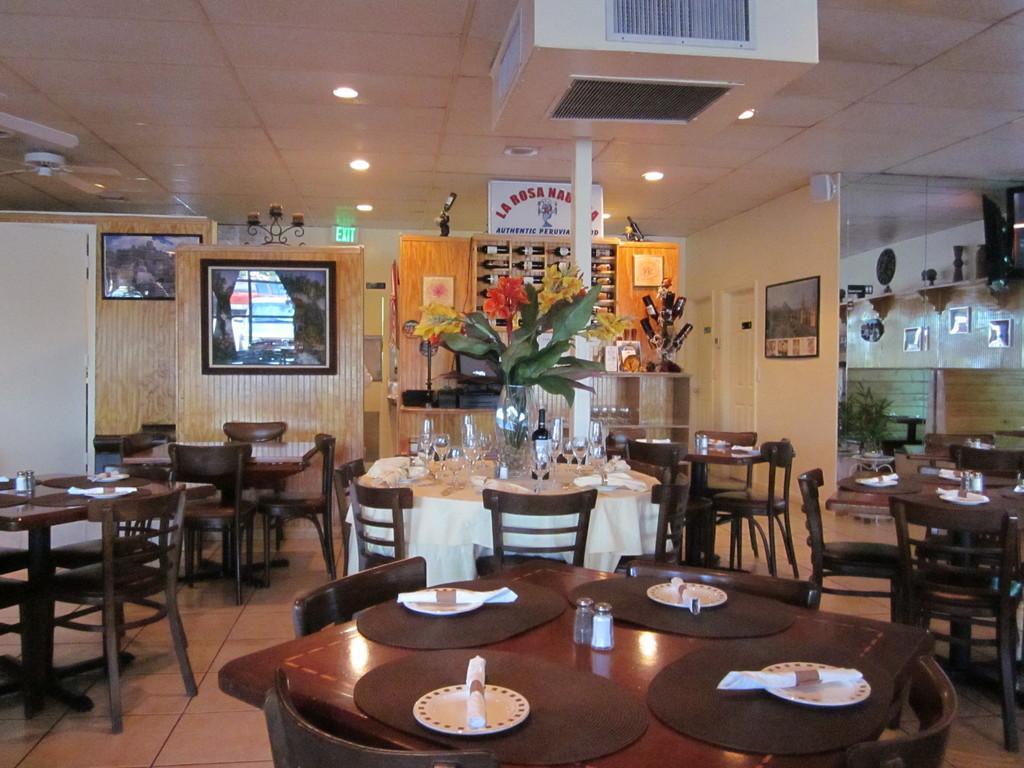Describe this image in one or two sentences. It looks like a dining room, there are dining tables, chairs in this room. On the roof there are lights. 